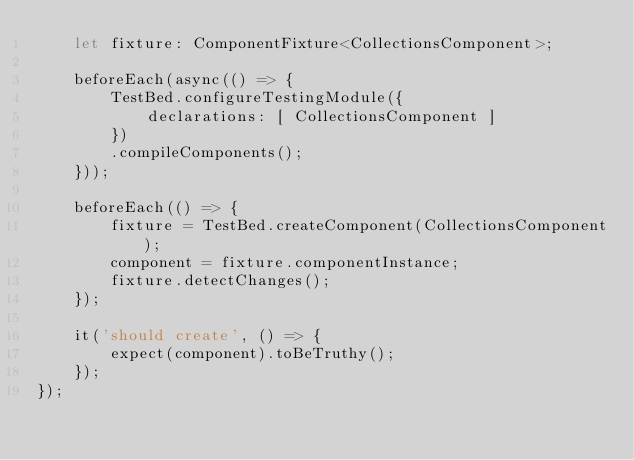Convert code to text. <code><loc_0><loc_0><loc_500><loc_500><_TypeScript_>    let fixture: ComponentFixture<CollectionsComponent>;

    beforeEach(async(() => {
        TestBed.configureTestingModule({
            declarations: [ CollectionsComponent ]
        })
        .compileComponents();
    }));

    beforeEach(() => {
        fixture = TestBed.createComponent(CollectionsComponent);
        component = fixture.componentInstance;
        fixture.detectChanges();
    });

    it('should create', () => {
        expect(component).toBeTruthy();
    });
});
</code> 